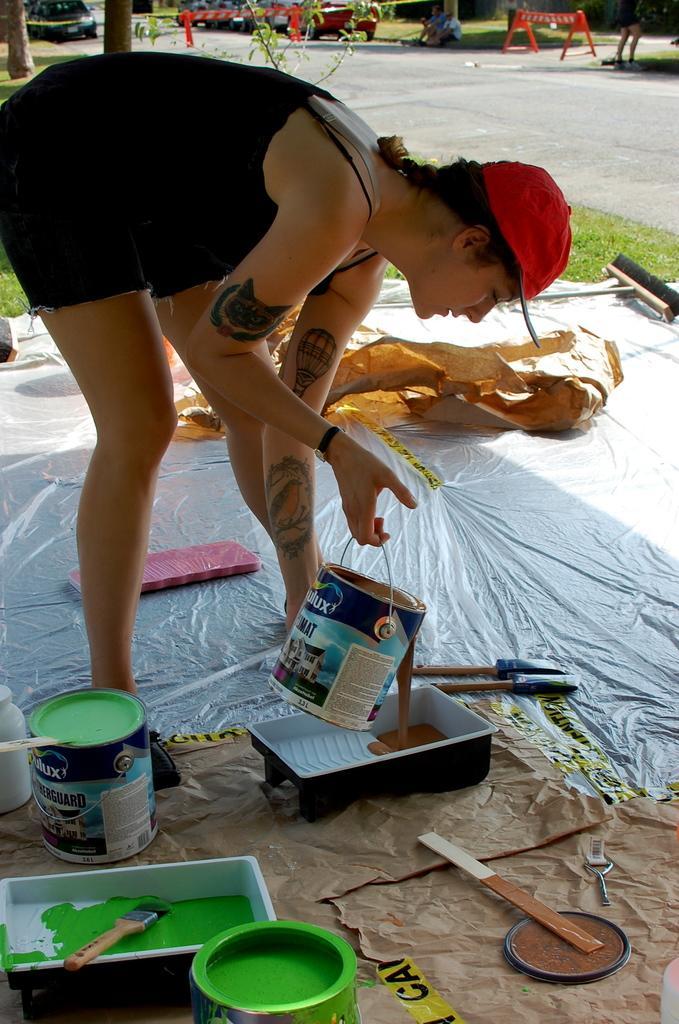Please provide a concise description of this image. At the bottom of the image we can see some tins, boxes and brushes. In the middle of the image a woman is standing and holding a tin. Behind her we can see some trees, fencing and vehicles on the road. At the top of the image two persons are sitting. 